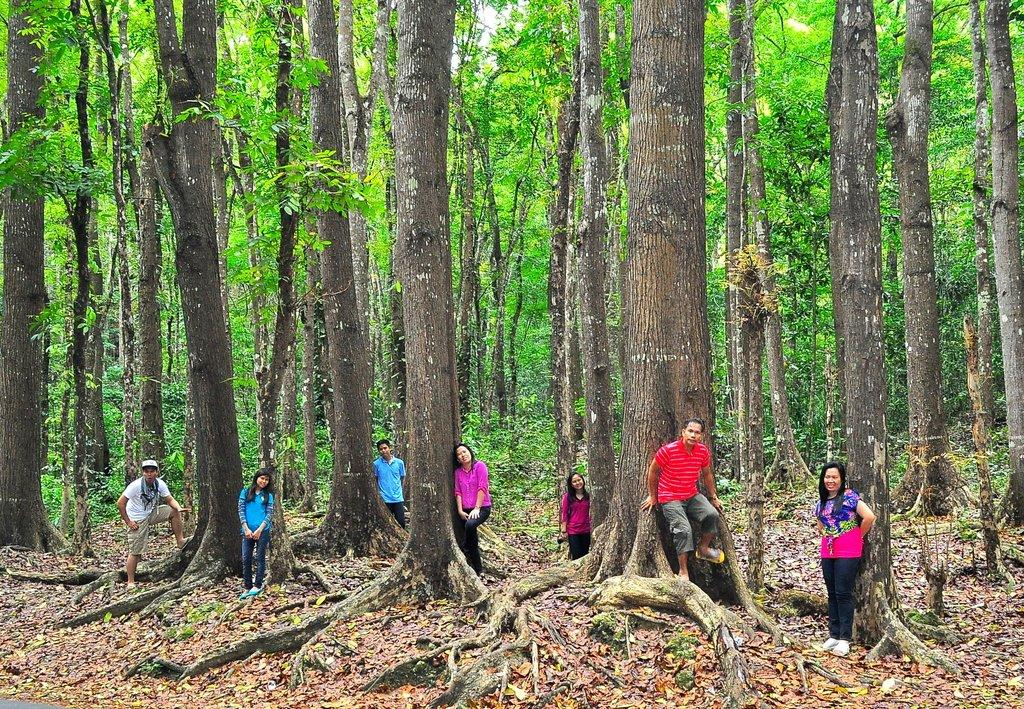What can be seen in the image involving human subjects? There are people standing in the image. What are the people wearing? The people are wearing clothes. What type of natural environment is present in the image? There are trees and dry grass in the image. What is the color of the sky in the image? The sky is white in the image. How many babies are crawling on the square in the image? There are no babies or squares present in the image. 